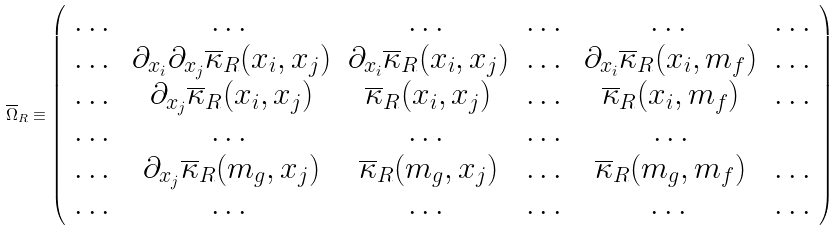Convert formula to latex. <formula><loc_0><loc_0><loc_500><loc_500>\overline { \Omega } _ { R } \equiv \left ( \begin{array} { c c c c c c } \dots & \dots & \dots & \dots & \dots & \dots \\ \dots & \partial _ { x _ { i } } \partial _ { x _ { j } } \overline { \kappa } _ { R } ( x _ { i } , x _ { j } ) & \partial _ { x _ { i } } \overline { \kappa } _ { R } ( x _ { i } , x _ { j } ) & \dots & \partial _ { x _ { i } } \overline { \kappa } _ { R } ( x _ { i } , m _ { f } ) & \dots \\ \dots & \partial _ { x _ { j } } \overline { \kappa } _ { R } ( x _ { i } , x _ { j } ) & \overline { \kappa } _ { R } ( x _ { i } , x _ { j } ) & \dots & \overline { \kappa } _ { R } ( x _ { i } , m _ { f } ) & \dots \\ \dots & \dots & \dots & \dots & \dots \\ \dots & \partial _ { x _ { j } } \overline { \kappa } _ { R } ( m _ { g } , x _ { j } ) & \overline { \kappa } _ { R } ( m _ { g } , x _ { j } ) & \dots & \overline { \kappa } _ { R } ( m _ { g } , m _ { f } ) & \dots \\ \dots & \dots & \dots & \dots & \dots & \dots \\ \end{array} \right )</formula> 